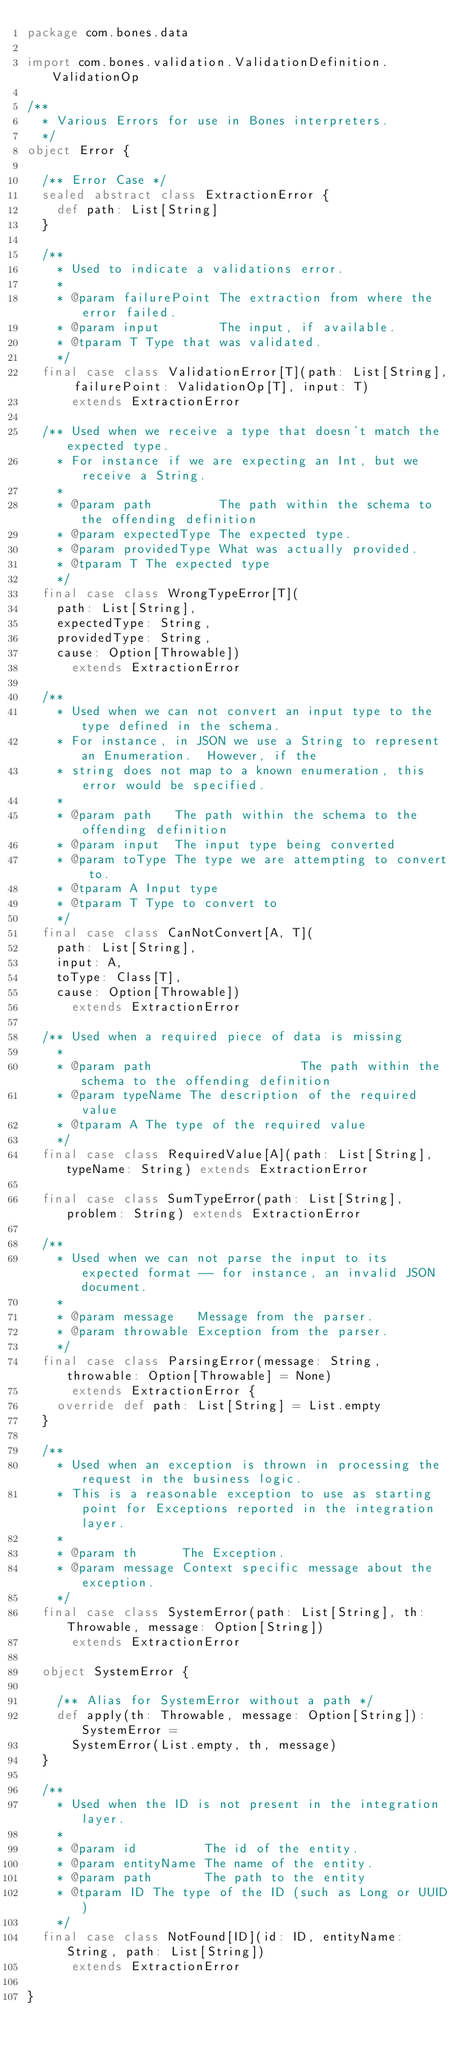<code> <loc_0><loc_0><loc_500><loc_500><_Scala_>package com.bones.data

import com.bones.validation.ValidationDefinition.ValidationOp

/**
  * Various Errors for use in Bones interpreters.
  */
object Error {

  /** Error Case */
  sealed abstract class ExtractionError {
    def path: List[String]
  }

  /**
    * Used to indicate a validations error.
    *
    * @param failurePoint The extraction from where the error failed.
    * @param input        The input, if available.
    * @tparam T Type that was validated.
    */
  final case class ValidationError[T](path: List[String], failurePoint: ValidationOp[T], input: T)
      extends ExtractionError

  /** Used when we receive a type that doesn't match the expected type.
    * For instance if we are expecting an Int, but we receive a String.
    *
    * @param path         The path within the schema to the offending definition
    * @param expectedType The expected type.
    * @param providedType What was actually provided.
    * @tparam T The expected type
    */
  final case class WrongTypeError[T](
    path: List[String],
    expectedType: String,
    providedType: String,
    cause: Option[Throwable])
      extends ExtractionError

  /**
    * Used when we can not convert an input type to the type defined in the schema.
    * For instance, in JSON we use a String to represent an Enumeration.  However, if the
    * string does not map to a known enumeration, this error would be specified.
    *
    * @param path   The path within the schema to the offending definition
    * @param input  The input type being converted
    * @param toType The type we are attempting to convert to.
    * @tparam A Input type
    * @tparam T Type to convert to
    */
  final case class CanNotConvert[A, T](
    path: List[String],
    input: A,
    toType: Class[T],
    cause: Option[Throwable])
      extends ExtractionError

  /** Used when a required piece of data is missing
    *
    * @param path                    The path within the schema to the offending definition
    * @param typeName The description of the required value
    * @tparam A The type of the required value
    */
  final case class RequiredValue[A](path: List[String], typeName: String) extends ExtractionError

  final case class SumTypeError(path: List[String], problem: String) extends ExtractionError

  /**
    * Used when we can not parse the input to its expected format -- for instance, an invalid JSON document.
    *
    * @param message   Message from the parser.
    * @param throwable Exception from the parser.
    */
  final case class ParsingError(message: String, throwable: Option[Throwable] = None)
      extends ExtractionError {
    override def path: List[String] = List.empty
  }

  /**
    * Used when an exception is thrown in processing the request in the business logic.
    * This is a reasonable exception to use as starting point for Exceptions reported in the integration layer.
    *
    * @param th      The Exception.
    * @param message Context specific message about the exception.
    */
  final case class SystemError(path: List[String], th: Throwable, message: Option[String])
      extends ExtractionError

  object SystemError {

    /** Alias for SystemError without a path */
    def apply(th: Throwable, message: Option[String]): SystemError =
      SystemError(List.empty, th, message)
  }

  /**
    * Used when the ID is not present in the integration layer.
    *
    * @param id         The id of the entity.
    * @param entityName The name of the entity.
    * @param path       The path to the entity
    * @tparam ID The type of the ID (such as Long or UUID)
    */
  final case class NotFound[ID](id: ID, entityName: String, path: List[String])
      extends ExtractionError

}
</code> 